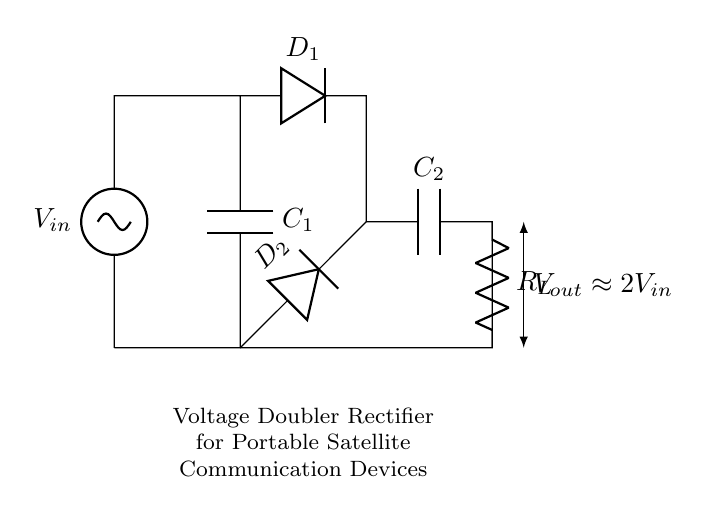What is the input voltage of this circuit? The input voltage, denoted by the symbol V_in on the circuit diagram, is the voltage supplied to the rectifier circuit.
Answer: V_in What are the circuit components used in this voltage doubler rectifier? The circuit diagram includes two capacitors (C_1 and C_2), two diodes (D_1 and D_2), and a resistor (R_L). These components are essential for the rectification process and voltage doubling effect.
Answer: Capacitors, diodes, resistor How many diodes are present in the circuit? The circuit diagram has two diodes, labeled D_1 and D_2, which perform the function of allowing current to flow in one direction only, essential for rectification.
Answer: 2 What is the output voltage of the circuit? The output voltage is indicated within the circuit as V_out, which is approximately equal to 2 times the input voltage V_in, reflecting the voltage-doubling function of the circuit.
Answer: 2V_in What role does capacitor C_2 play in this rectifier? Capacitor C_2 is used to store charge and smooth out the output voltage, ensuring a more stable and higher voltage output after rectification, contributing to the voltage doubling effect.
Answer: Voltage stabilization Why is this circuit termed a voltage doubler? The circuit is referred to as a voltage doubler because it converts the input AC voltage to a DC voltage that is approximately double the input voltage (2V_in), achieved through the arrangement of diodes and capacitors.
Answer: Voltage doubler 